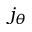<formula> <loc_0><loc_0><loc_500><loc_500>j _ { \theta }</formula> 